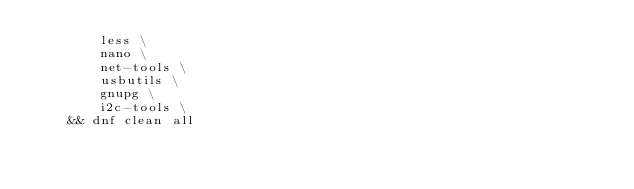<code> <loc_0><loc_0><loc_500><loc_500><_Dockerfile_>		less \
		nano \
		net-tools \
		usbutils \
		gnupg \
		i2c-tools \
	&& dnf clean all
</code> 